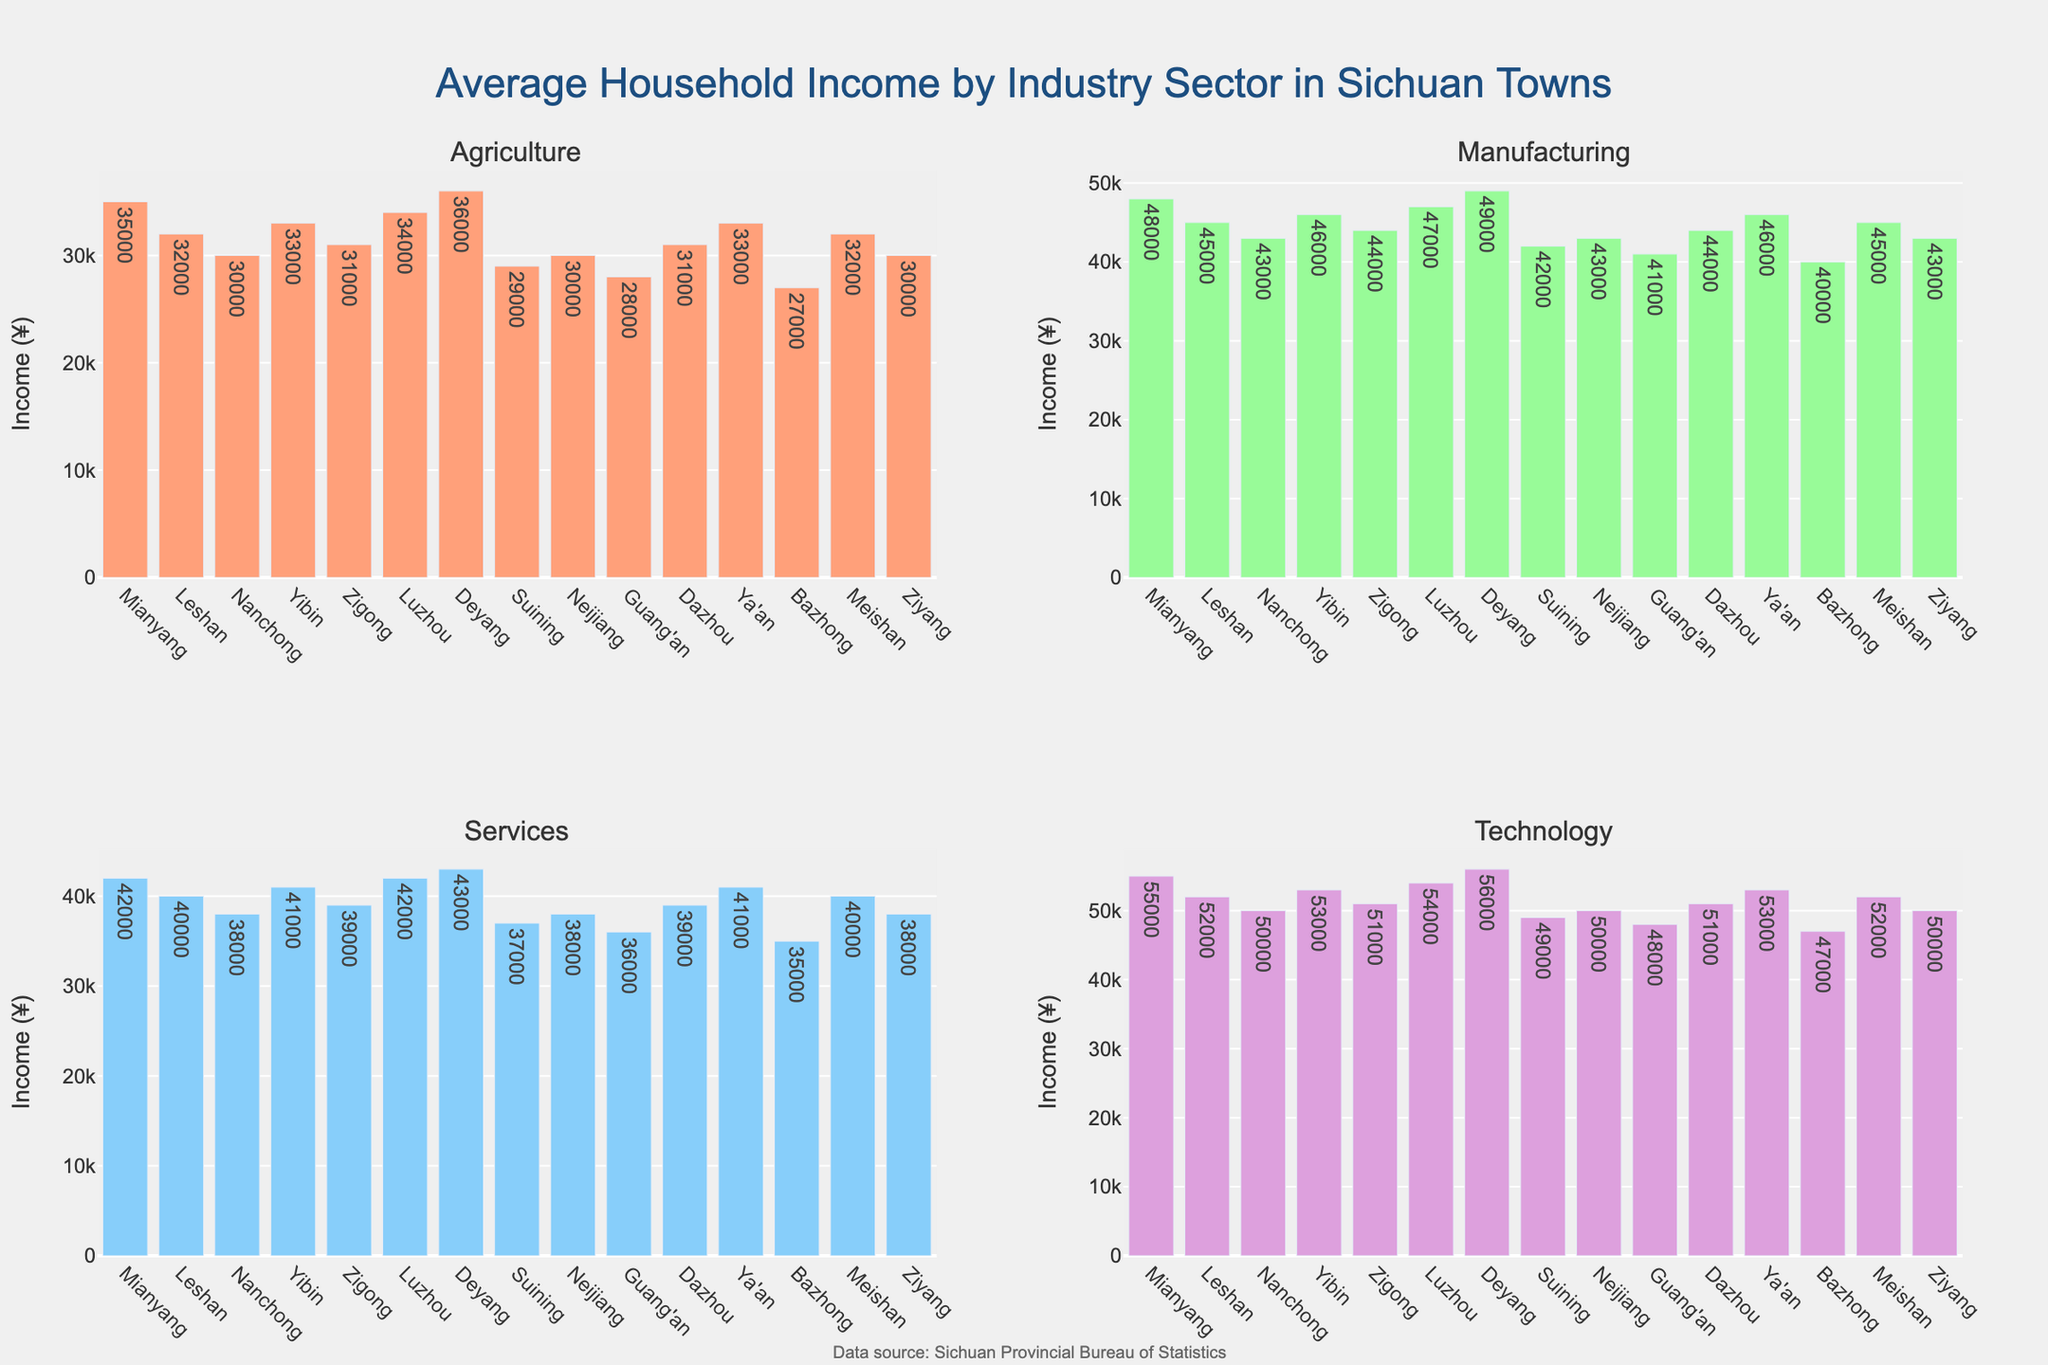Which town has the highest average household income in the Technology sector? To answer this, look at the bar heights in the Technology subplot. The tallest bar corresponds to Deyang, with an income of ¥56,000.
Answer: Deyang Compare the average household income in the Manufacturing sector between Mianyang and Leshan. Which one is higher and by how much? Check the Manufacturing subplot and compare the bars for Mianyang and Leshan. Mianyang has ¥48,000 and Leshan has ¥45,000. The difference is ¥3,000.
Answer: Mianyang, ¥3,000 Which town has the lowest average household income in the Agriculture sector, and what is the amount? Observe the bar heights in the Agriculture subplot. The shortest bar is for Bazhong, which has an income of ¥27,000.
Answer: Bazhong, ¥27,000 What is the total average household income from all sectors for Nanchong? Sum the incomes for Nanchong across all sectors: Agriculture ¥30,000, Manufacturing ¥43,000, Services ¥38,000, Technology ¥50,000. The total is 30,000 + 43,000 + 38,000 + 50,000 = ¥161,000.
Answer: ¥161,000 Which sector has the widest variation in average household income across all towns? Look at the range of bar heights within each subplot. The Technology sector shows the most variation from Guang'an with ¥48,000 to Deyang with ¥56,000.
Answer: Technology Is the average household income in the Services sector for Mianyang higher than the income in the Technology sector for Suining? Check the Services subplot for Mianyang (¥42,000) and the Technology subplot for Suining (¥49,000). Suining's Technology sector is higher.
Answer: No What is the difference in average household income in the Agriculture sector between the highest and lowest towns? Find the highest (Deyang, ¥36,000) and lowest (Bazhong, ¥27,000) incomes in the Agriculture sector. The difference is 36,000 - 27,000 = ¥9,000.
Answer: ¥9,000 How does the average household income in the Services sector for Yibin compare to that in the Manufacturing sector in Dazhou? Look at the Services subplot for Yibin (¥41,000) and the Manufacturing subplot for Dazhou (¥44,000). Dazhou's Manufacturing sector is higher.
Answer: Lower Find the town with the most consistent average household income across all sectors (defined as the smallest range between highest and lowest incomes). Calculate the range for each town (difference between highest and lowest incomes):
- Bazhong: 40,000 - 27,000 = 13,000
- Guang'an: 48,000 - 28,000 = 20,000
- [Continue for all towns]
Dazhou shows a range of 44,000 - 31,000 = 13,000 which is one of the smallest.
Answer: Dazhou 